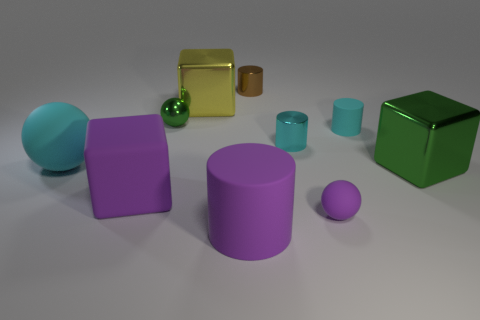What number of things are large brown rubber spheres or purple things in front of the tiny matte ball?
Give a very brief answer. 1. Do the green object on the right side of the brown object and the purple ball have the same material?
Offer a very short reply. No. The matte cube that is the same size as the cyan matte ball is what color?
Your response must be concise. Purple. Is there a cyan thing that has the same shape as the yellow thing?
Offer a very short reply. No. What color is the large rubber thing that is in front of the matte cube behind the small ball right of the purple matte cylinder?
Offer a very short reply. Purple. What number of rubber objects are either small cyan blocks or brown things?
Your answer should be compact. 0. Are there more large green cubes in front of the large cyan rubber ball than objects that are on the left side of the purple rubber block?
Offer a very short reply. No. What number of other things are the same size as the purple matte cube?
Offer a very short reply. 4. There is a rubber ball that is in front of the green metal thing that is right of the tiny green ball; what size is it?
Provide a succinct answer. Small. What number of small objects are either balls or cyan matte balls?
Make the answer very short. 2. 